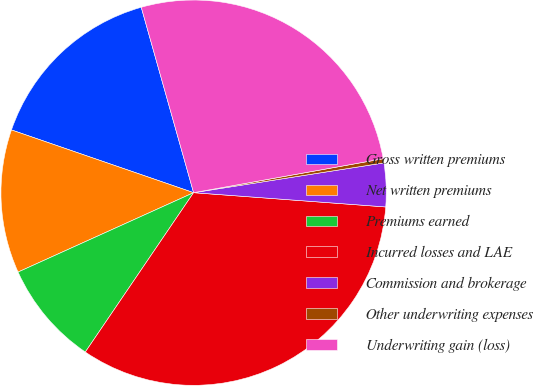Convert chart. <chart><loc_0><loc_0><loc_500><loc_500><pie_chart><fcel>Gross written premiums<fcel>Net written premiums<fcel>Premiums earned<fcel>Incurred losses and LAE<fcel>Commission and brokerage<fcel>Other underwriting expenses<fcel>Underwriting gain (loss)<nl><fcel>15.34%<fcel>12.04%<fcel>8.74%<fcel>33.32%<fcel>3.65%<fcel>0.35%<fcel>26.56%<nl></chart> 